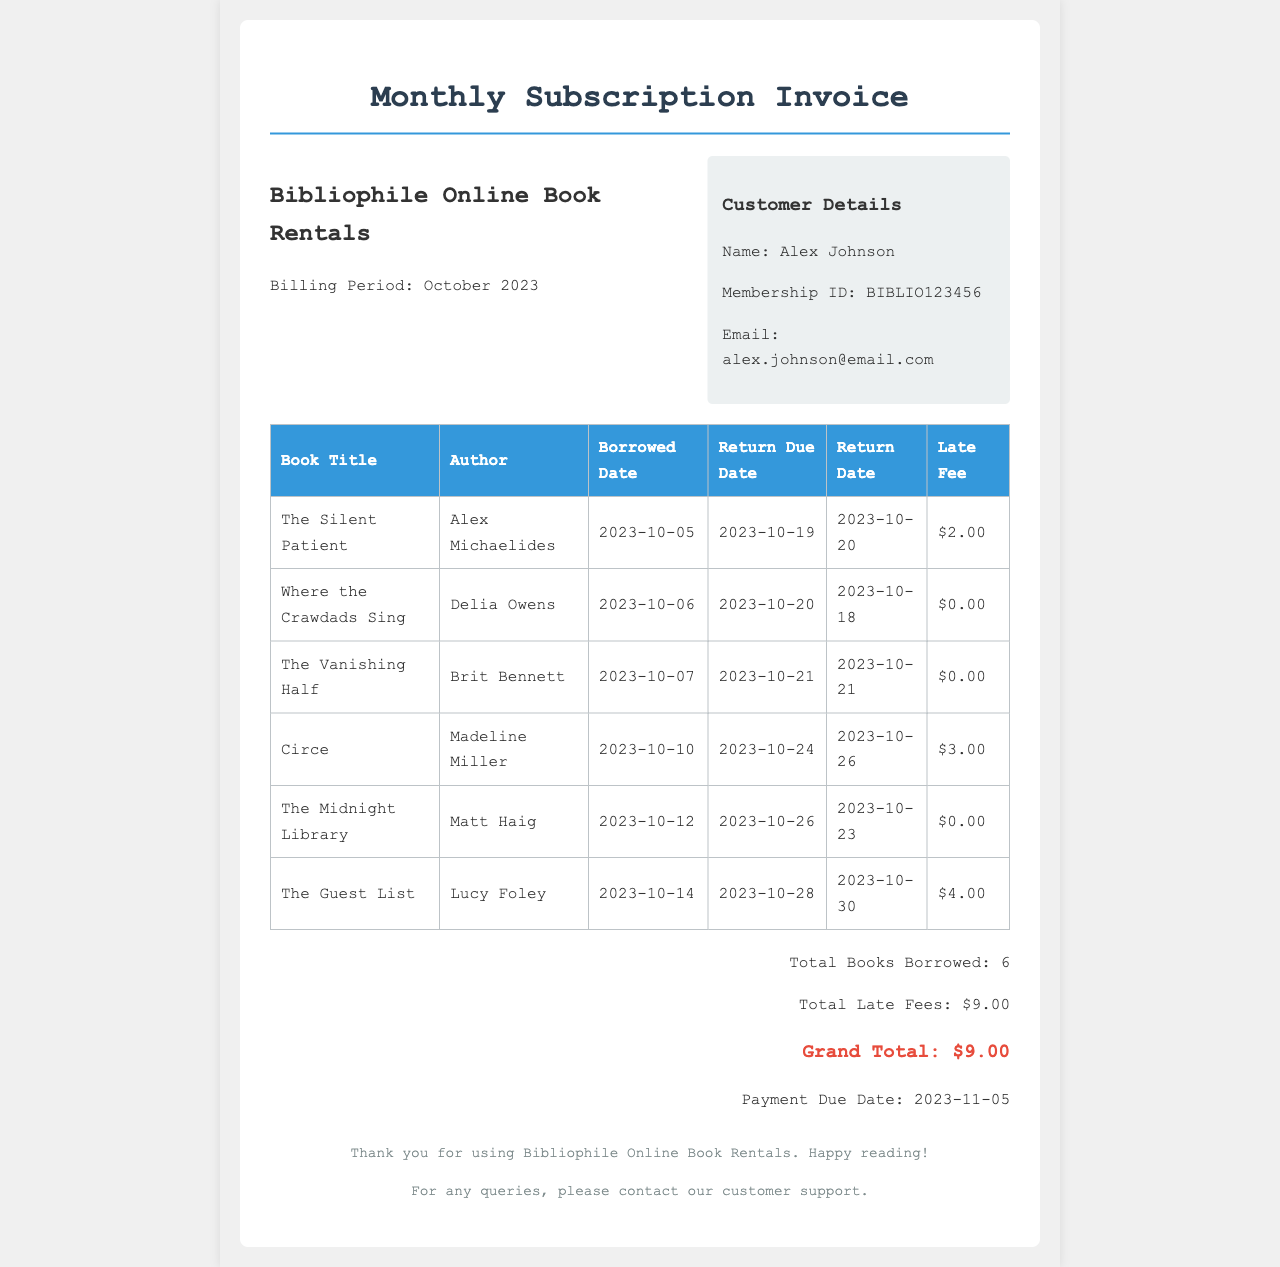What is the billing period? The billing period is indicated in the header of the invoice and specifies the timeframe for which the subscription is billed.
Answer: October 2023 Who is the customer? The customer details section provides the name of the individual who holds the membership.
Answer: Alex Johnson What is the total number of books borrowed? The summary section lists the total number of books borrowed in the invoice.
Answer: 6 What is the total late fees? The summary section specifies the total amount charged for late fees for returned books.
Answer: $9.00 What is the payment due date? The summary section mentions the date by which the payment must be made.
Answer: 2023-11-05 How many books were returned late? To find this, one needs to check the return dates against the due dates in the table.
Answer: 3 What was the late fee for "The Guest List"? The late fee is provided in the table under the respective book title.
Answer: $4.00 Which book had the latest return date? The return dates in the table can be analyzed to determine the latest one.
Answer: The Guest List What is the name of the author for "The Silent Patient"? The table includes the specific author for each book, which provides this information.
Answer: Alex Michaelides 